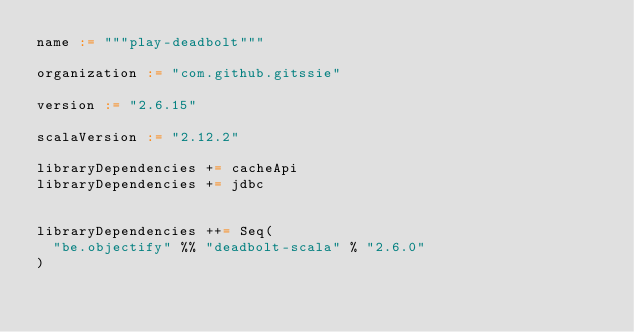Convert code to text. <code><loc_0><loc_0><loc_500><loc_500><_Scala_>name := """play-deadbolt"""

organization := "com.github.gitssie"

version := "2.6.15"

scalaVersion := "2.12.2"

libraryDependencies += cacheApi
libraryDependencies += jdbc


libraryDependencies ++= Seq(
  "be.objectify" %% "deadbolt-scala" % "2.6.0"
)</code> 